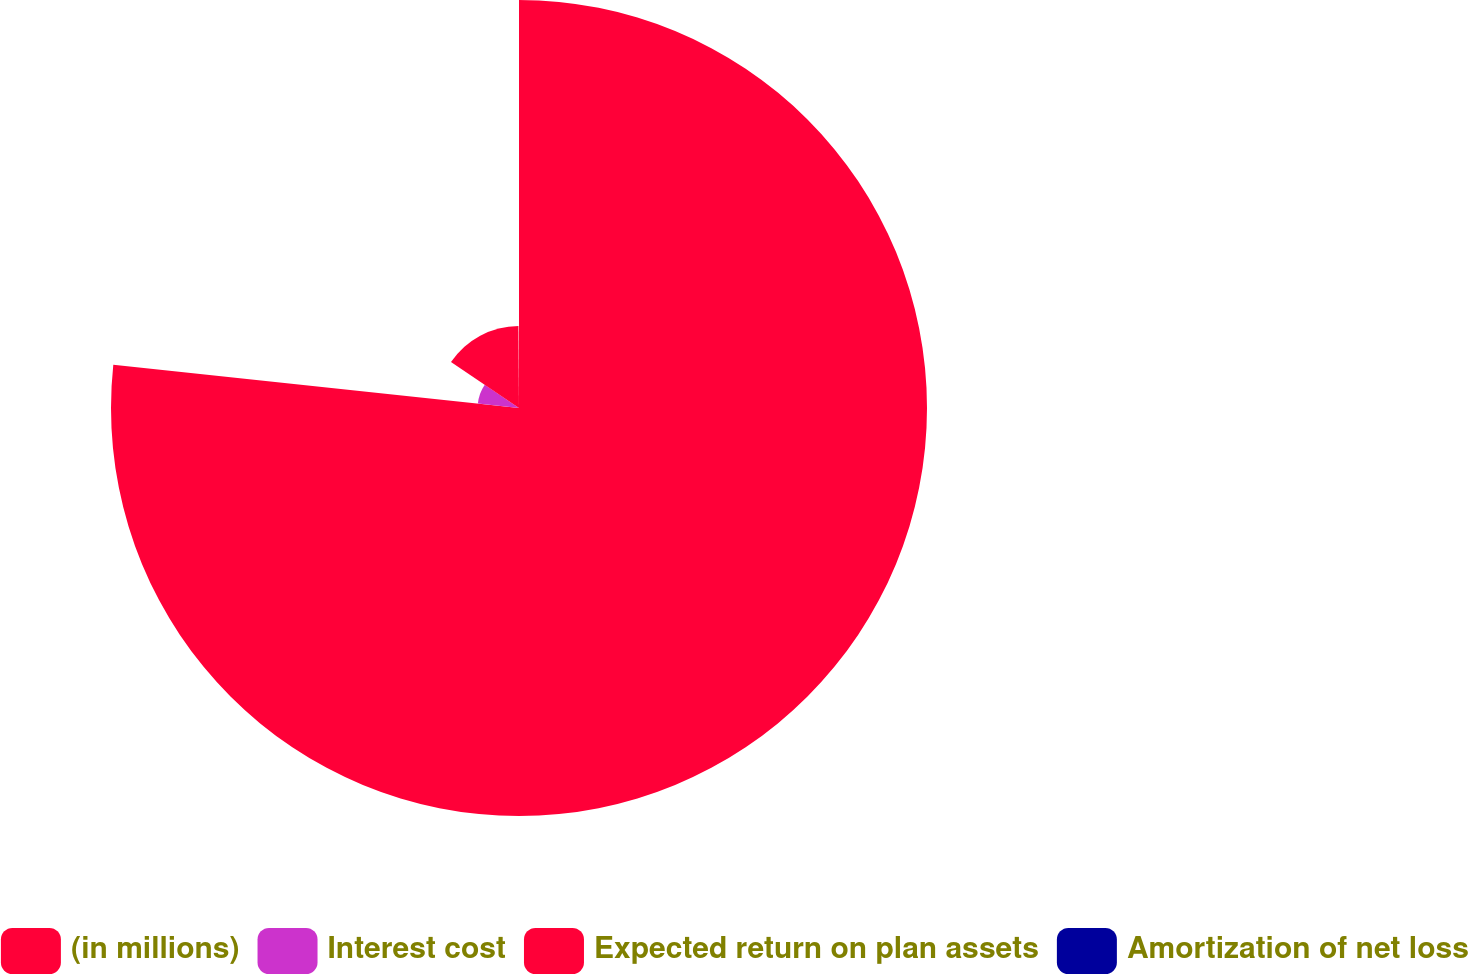<chart> <loc_0><loc_0><loc_500><loc_500><pie_chart><fcel>(in millions)<fcel>Interest cost<fcel>Expected return on plan assets<fcel>Amortization of net loss<nl><fcel>76.69%<fcel>7.77%<fcel>15.43%<fcel>0.11%<nl></chart> 